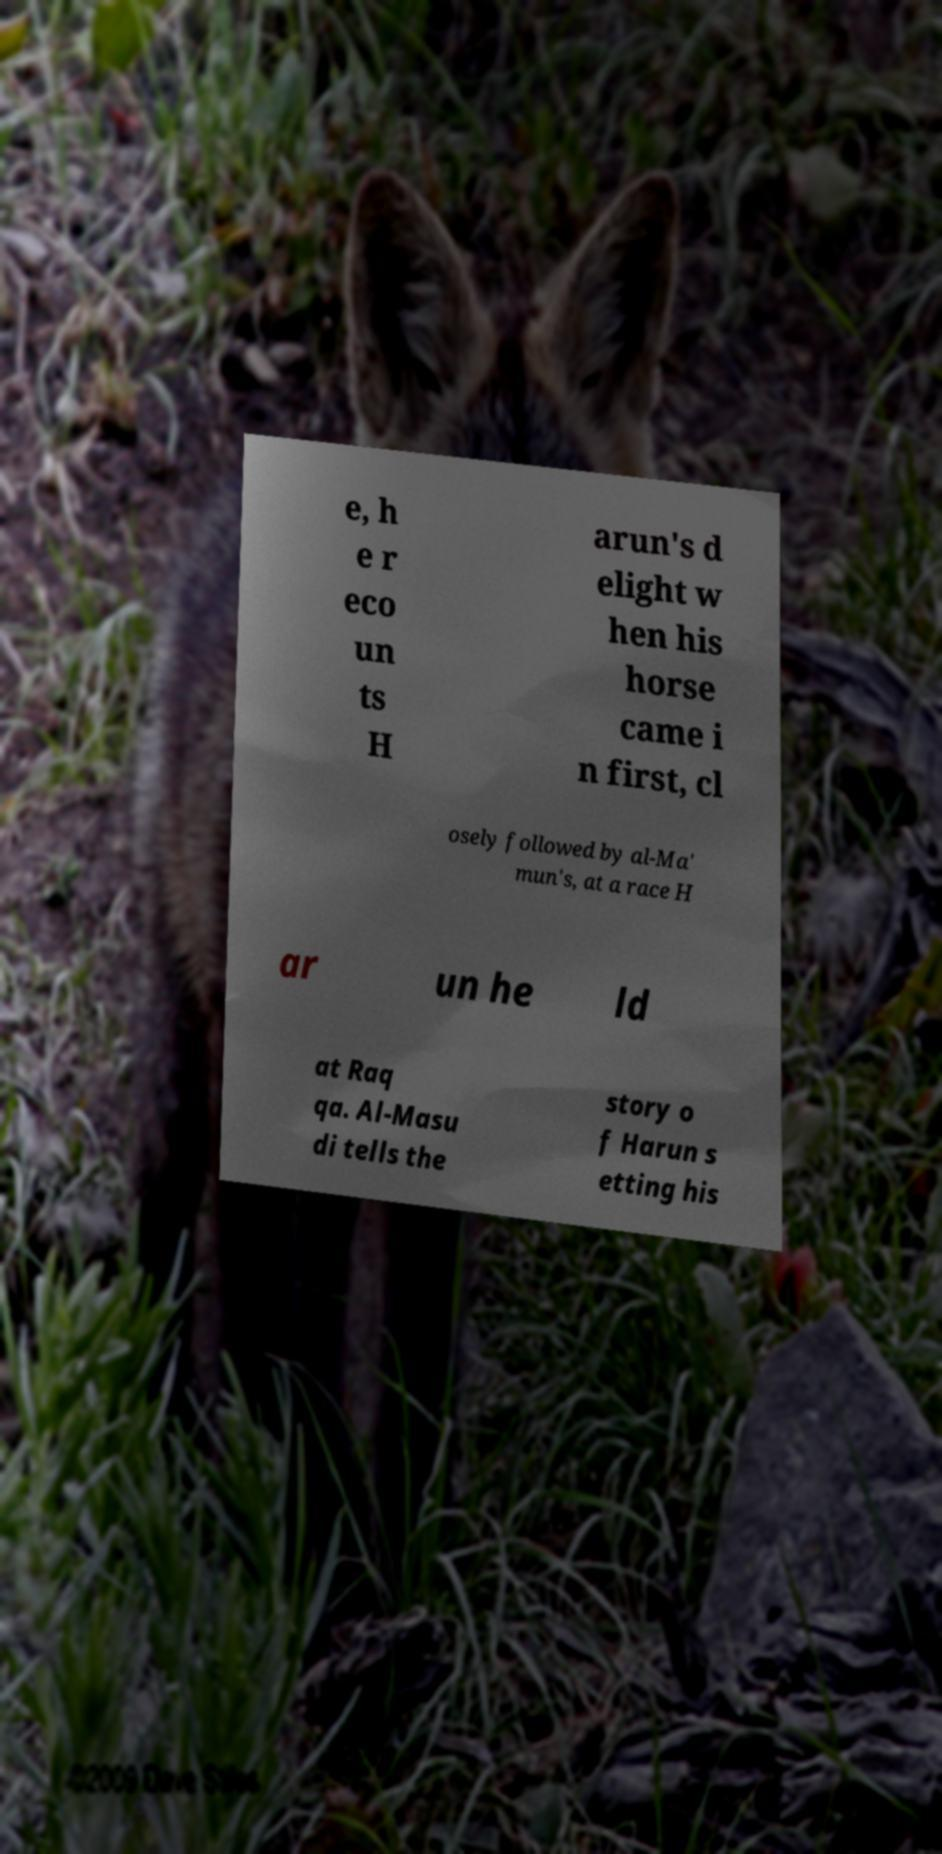Please identify and transcribe the text found in this image. e, h e r eco un ts H arun's d elight w hen his horse came i n first, cl osely followed by al-Ma' mun's, at a race H ar un he ld at Raq qa. Al-Masu di tells the story o f Harun s etting his 